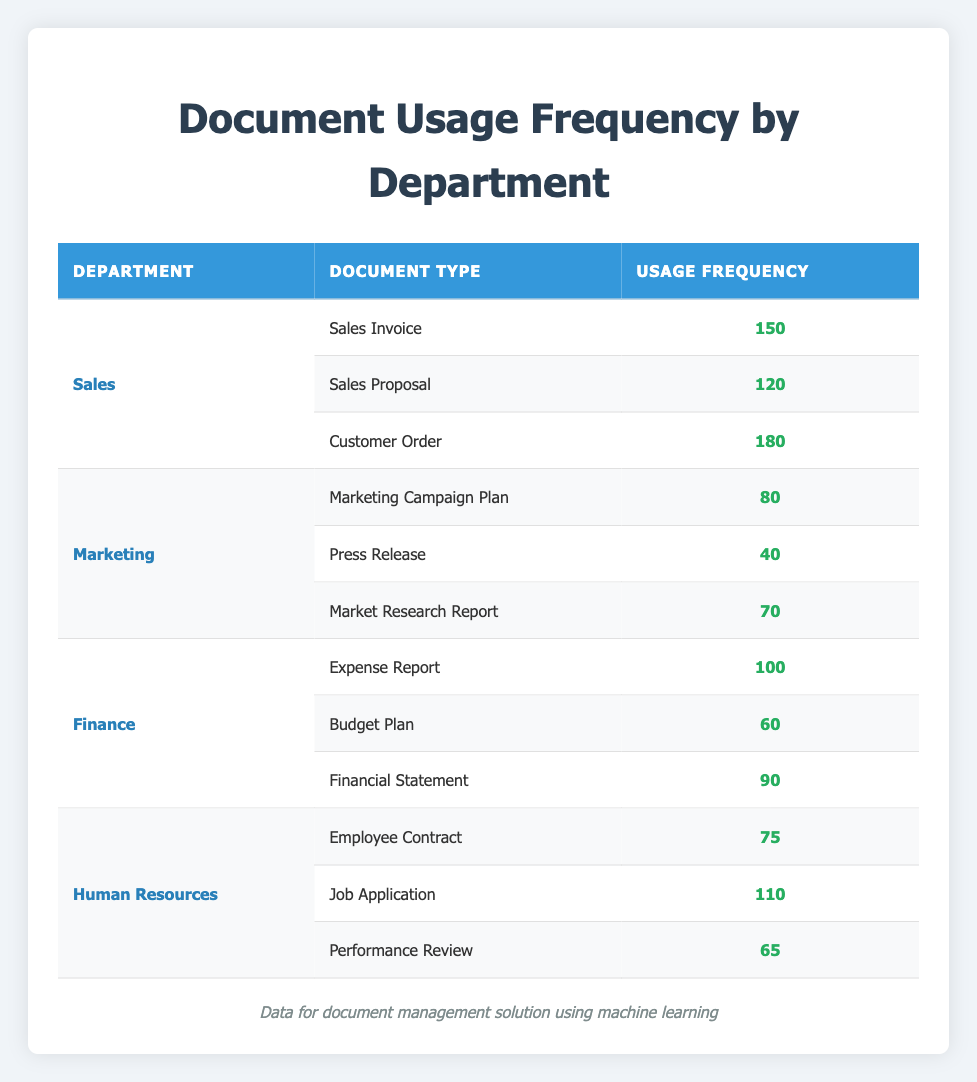What is the highest usage frequency document type in the Sales department? The highest usage frequency is found by examining the "Usage Frequency" column for the "Sales" department. The values are 150 for "Sales Invoice", 120 for "Sales Proposal", and 180 for "Customer Order". Comparing these, the highest is 180 for "Customer Order".
Answer: 180 Which department has the lowest total usage frequency for documents? To find the lowest total usage frequency, calculate the total for each department: Sales (150 + 120 + 180 = 450), Marketing (80 + 40 + 70 = 190), Finance (100 + 60 + 90 = 250), and Human Resources (75 + 110 + 65 = 250). Marketing has the lowest total of 190.
Answer: Marketing Is the usage frequency of "Press Release" greater than "Job Application"? Comparing the values, "Press Release" has a frequency of 40, while "Job Application" has 110. Since 40 is not greater than 110, the answer is no.
Answer: No What is the average usage frequency of documents in the Finance department? The average usage frequency for Finance is calculated by adding the usage values (100 + 60 + 90 = 250) and dividing by the number of document types (3). So, 250 / 3 equals approximately 83.33.
Answer: 83.33 Which document type in the Human Resources department has the highest usage frequency? In the Human Resources department, the usage frequencies are 75 for "Employee Contract", 110 for "Job Application", and 65 for "Performance Review". The highest frequency, 110, is for "Job Application".
Answer: Job Application What is the total usage frequency for all departments combined? To calculate the total usage frequency, sum all individual usage frequencies: (150 + 120 + 180 + 80 + 40 + 70 + 100 + 60 + 90 + 75 + 110 + 65). This totals 1,200.
Answer: 1200 Is there any document type usage frequency of exactly 60? Checking the usage frequency for all document types, only the "Budget Plan" in the Finance department has a usage frequency of 60.
Answer: Yes Which department has a higher average usage frequency: Sales or Human Resources? Calculate the averages: Sales has 450 total across 3 document types (450 / 3 = 150), and Human Resources has 250 total across 3 types (250 / 3 = 83.33). Since 150 is greater than 83.33, Sales has a higher average.
Answer: Sales 